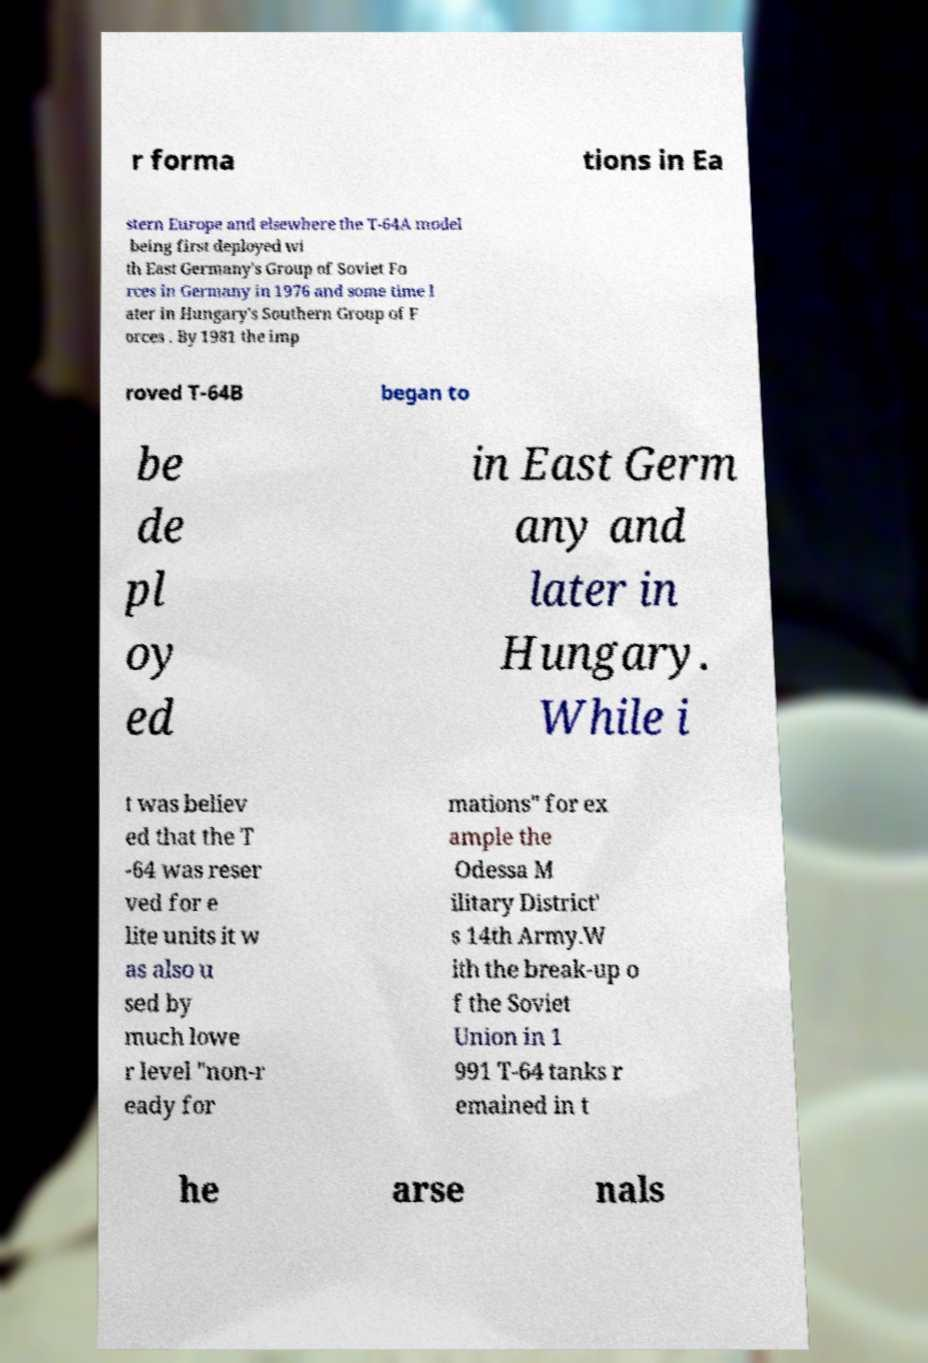Could you extract and type out the text from this image? r forma tions in Ea stern Europe and elsewhere the T-64A model being first deployed wi th East Germany's Group of Soviet Fo rces in Germany in 1976 and some time l ater in Hungary's Southern Group of F orces . By 1981 the imp roved T-64B began to be de pl oy ed in East Germ any and later in Hungary. While i t was believ ed that the T -64 was reser ved for e lite units it w as also u sed by much lowe r level "non-r eady for mations" for ex ample the Odessa M ilitary District' s 14th Army.W ith the break-up o f the Soviet Union in 1 991 T-64 tanks r emained in t he arse nals 